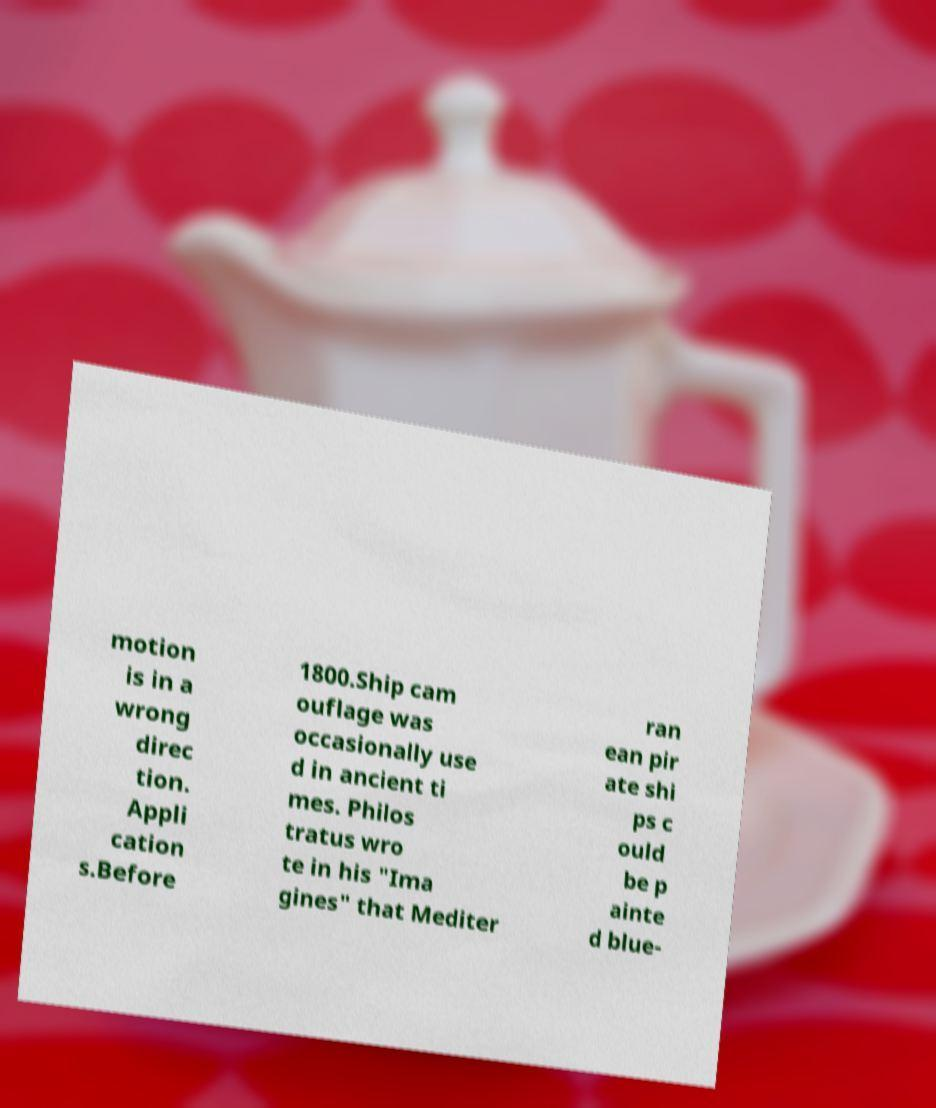Can you read and provide the text displayed in the image?This photo seems to have some interesting text. Can you extract and type it out for me? motion is in a wrong direc tion. Appli cation s.Before 1800.Ship cam ouflage was occasionally use d in ancient ti mes. Philos tratus wro te in his "Ima gines" that Mediter ran ean pir ate shi ps c ould be p ainte d blue- 